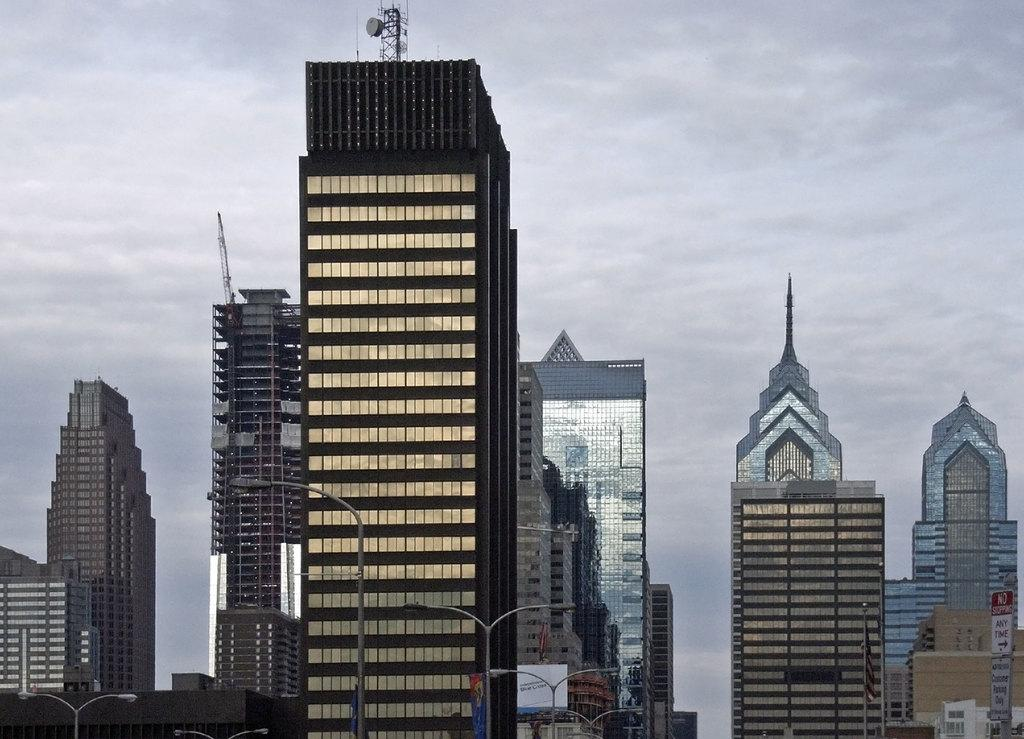What type of structures are visible in the image? There are big buildings in the image. What can be seen illuminating the area in the image? There are street lights in the image. What type of signage is present in the image? There are boards with text in the image. What is located at the top of the buildings in the image? There are antennas at the top of the buildings in the image. What is the condition of the sky in the image? The sky is cloudy at the top of the image. What type of frame is used to hold the bricks together in the image? There are no bricks present in the image, so there is no frame holding them together. What type of scissors are used to cut the clouds in the image? There are no scissors or cloud-cutting activity depicted in the image. 